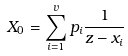Convert formula to latex. <formula><loc_0><loc_0><loc_500><loc_500>X _ { 0 } = \sum _ { i = 1 } ^ { v } p _ { i } \frac { 1 } { z - x _ { i } }</formula> 